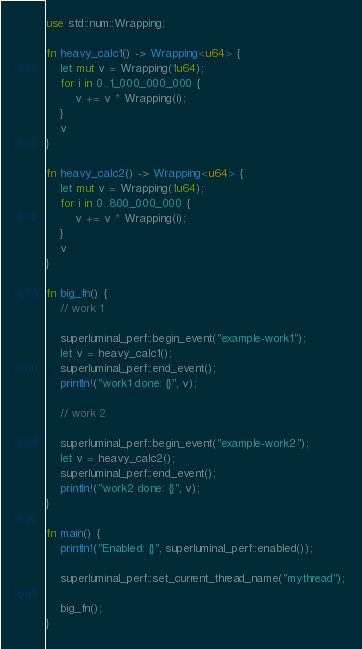<code> <loc_0><loc_0><loc_500><loc_500><_Rust_>use std::num::Wrapping;

fn heavy_calc1() -> Wrapping<u64> {
    let mut v = Wrapping(1u64);
    for i in 0..1_000_000_000 {
        v += v * Wrapping(i);
    }
    v
}

fn heavy_calc2() -> Wrapping<u64> {
    let mut v = Wrapping(1u64);
    for i in 0..800_000_000 {
        v += v * Wrapping(i);
    }
    v
}

fn big_fn() {
    // work 1

    superluminal_perf::begin_event("example-work1");
    let v = heavy_calc1();
    superluminal_perf::end_event();
    println!("work1 done: {}", v);

    // work 2

    superluminal_perf::begin_event("example-work2");
    let v = heavy_calc2();
    superluminal_perf::end_event();
    println!("work2 done: {}", v);
}

fn main() {
    println!("Enabled: {}", superluminal_perf::enabled());

    superluminal_perf::set_current_thread_name("mythread");

    big_fn();
}
</code> 